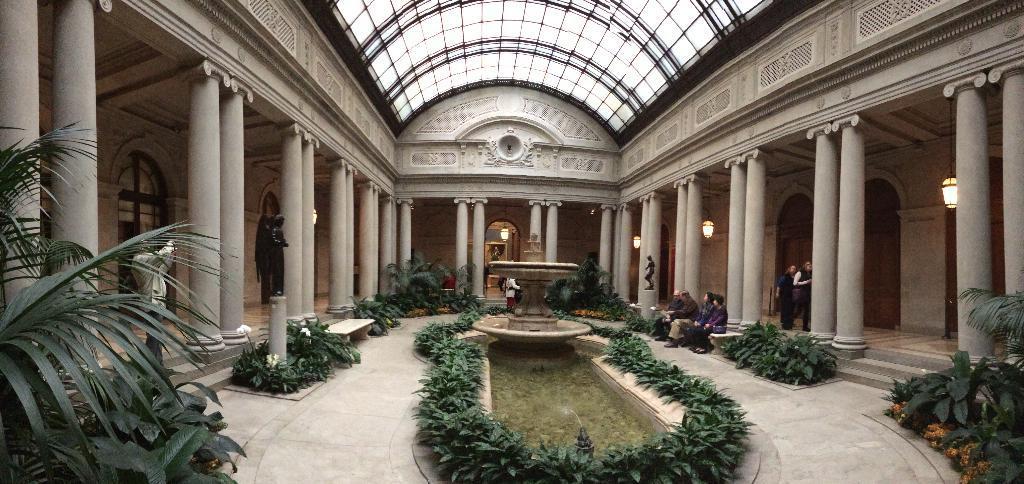Describe this image in one or two sentences. This is an inside view of a building and here we can see statues, lights, pillars, plants, and we can see some people and in the center, there is a fountain. At the bottom, there is floor and at the top, there is roof. 